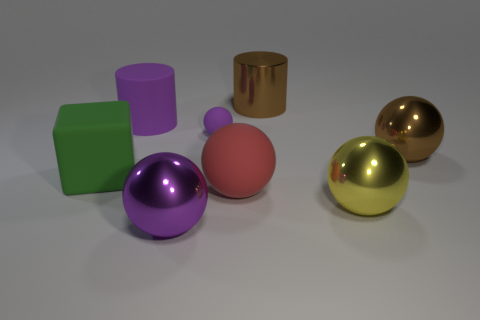How many other yellow objects are the same shape as the yellow thing?
Your answer should be very brief. 0. Does the tiny thing have the same color as the large rubber cylinder?
Your answer should be compact. Yes. What material is the purple object right of the large metallic object left of the rubber ball that is in front of the big brown metal ball?
Your answer should be compact. Rubber. Are there any purple balls to the right of the large green block?
Make the answer very short. Yes. There is a yellow shiny object that is the same size as the purple metallic ball; what is its shape?
Offer a very short reply. Sphere. Does the big cube have the same material as the yellow thing?
Ensure brevity in your answer.  No. How many matte objects are either big brown cubes or things?
Ensure brevity in your answer.  4. There is another rubber object that is the same color as the small matte object; what is its shape?
Offer a very short reply. Cylinder. Does the large cylinder to the left of the purple metallic sphere have the same color as the small thing?
Your answer should be very brief. Yes. The big matte thing that is in front of the green matte block that is in front of the big purple cylinder is what shape?
Give a very brief answer. Sphere. 